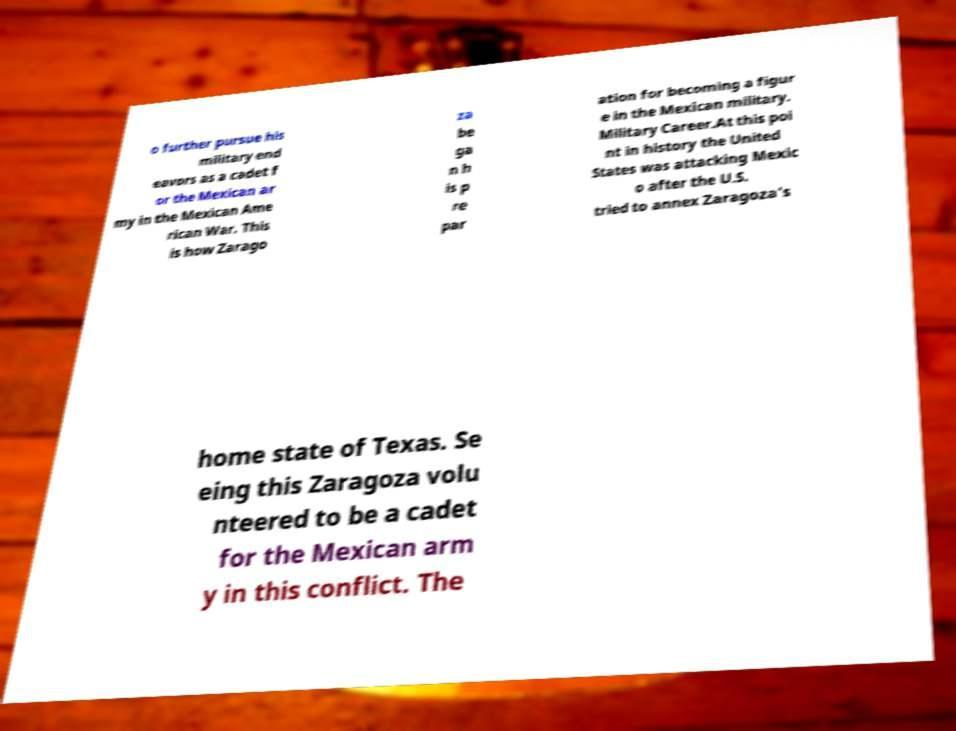What messages or text are displayed in this image? I need them in a readable, typed format. o further pursue his military end eavors as a cadet f or the Mexican ar my in the Mexican Ame rican War. This is how Zarago za be ga n h is p re par ation for becoming a figur e in the Mexican military. Military Career.At this poi nt in history the United States was attacking Mexic o after the U.S. tried to annex Zaragoza’s home state of Texas. Se eing this Zaragoza volu nteered to be a cadet for the Mexican arm y in this conflict. The 